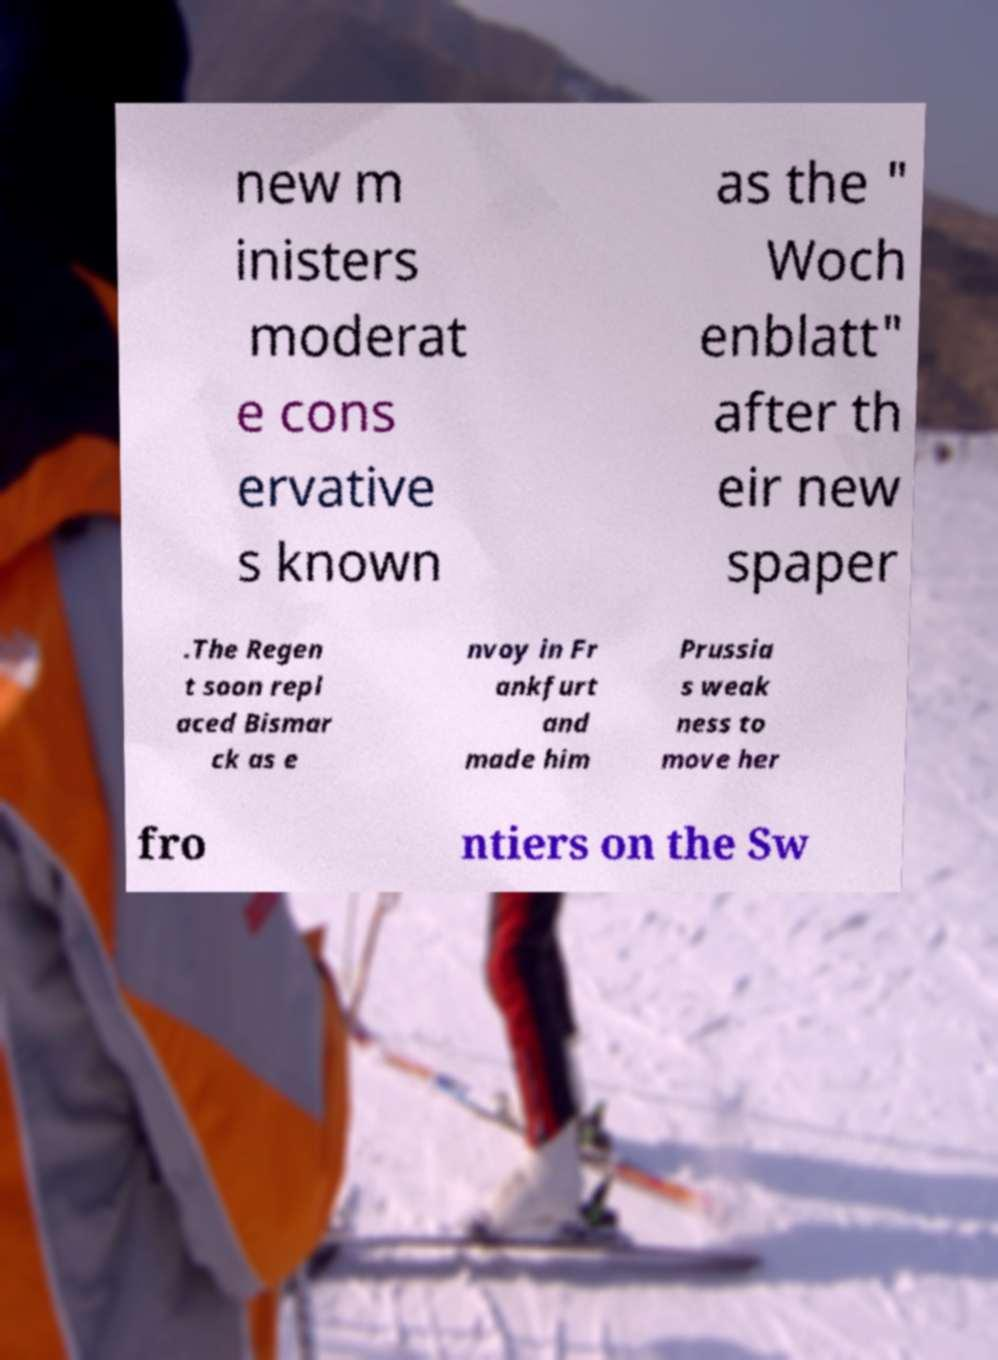I need the written content from this picture converted into text. Can you do that? new m inisters moderat e cons ervative s known as the " Woch enblatt" after th eir new spaper .The Regen t soon repl aced Bismar ck as e nvoy in Fr ankfurt and made him Prussia s weak ness to move her fro ntiers on the Sw 